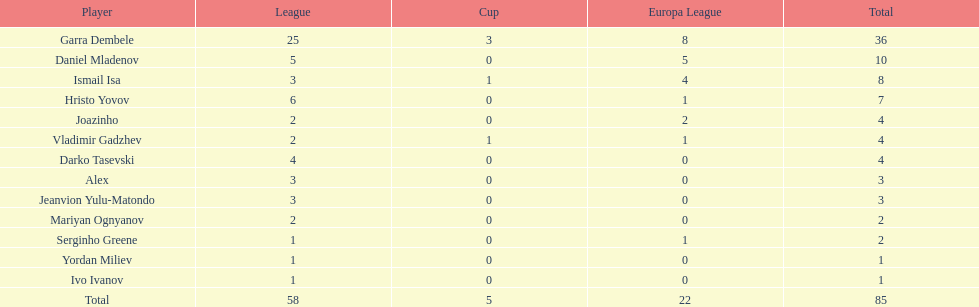How many players did not score a goal in cup play? 10. 